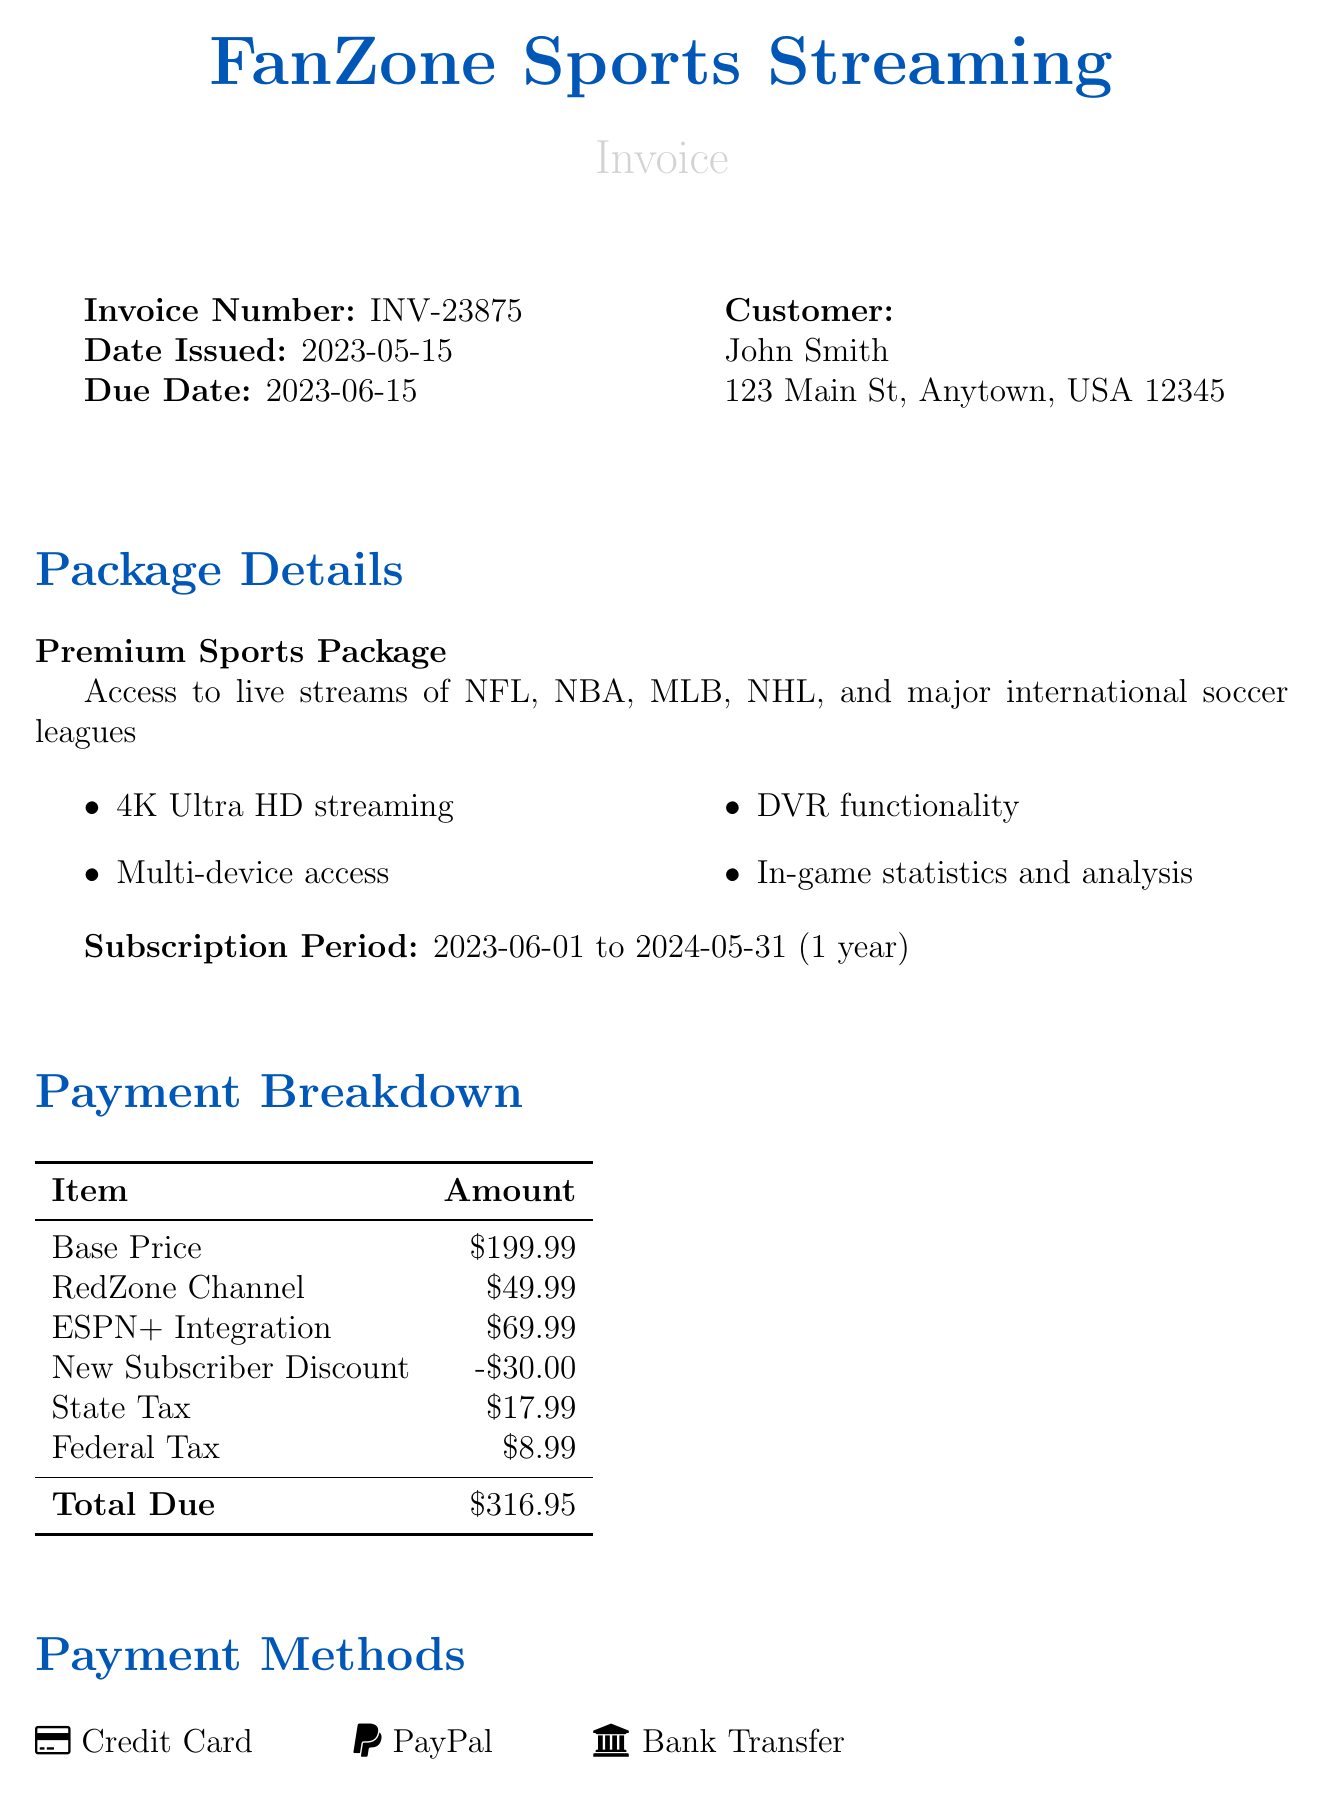What is the invoice number? The invoice number is listed at the top of the document.
Answer: INV-23875 Who is the customer? The customer's name is specified in the document as part of the customer information.
Answer: John Smith What is the total due for the subscription? The total due is calculated in the payment breakdown section of the document.
Answer: 316.95 What is the name of the streaming package? The name of the package is highlighted under package details.
Answer: Premium Sports Package What feature is not available in the current package? The special notes section mentions features not available in the customer's current package.
Answer: Sports wagering features What discount is applied to the subscription? The discount applied in the payment breakdown section is indicated by its name and amount.
Answer: New Subscriber Discount When does the subscription period start? The subscription period's start date is specified in the subscription period section.
Answer: 2023-06-01 What payment methods are accepted? The document lists various payment methods available to the customer.
Answer: Credit Card, PayPal, Bank Transfer What is the due date for this invoice? The due date is clearly mentioned in the document under invoice details.
Answer: 2023-06-15 